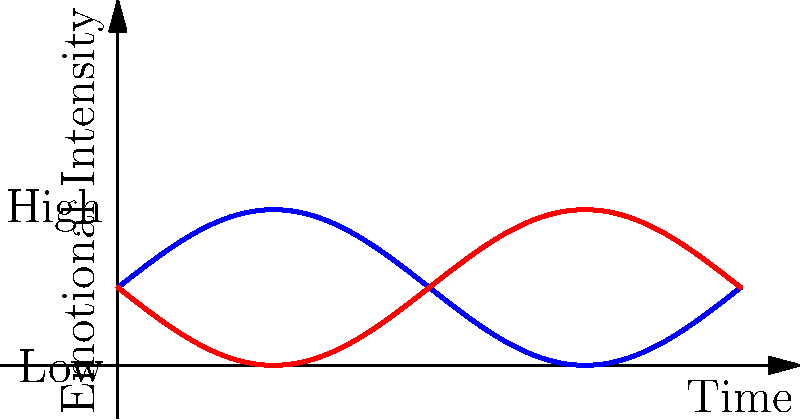As an expert in evaluating AI character realism, analyze the emotional trajectories of two characters over time as shown in the graph. What key observation can you make about the relationship between Character A's and Character B's emotional states, and how might this contribute to a more believable narrative arc? To analyze the emotional trajectories and their contribution to a believable narrative arc, let's break down the graph:

1. Character A (blue line):
   - Starts at a neutral emotional state
   - Rises to a peak of high emotional intensity around the midpoint
   - Returns to a neutral state by the end

2. Character B (red line):
   - Also starts at a neutral emotional state
   - Dips to a low point of emotional intensity around the midpoint
   - Returns to a neutral state by the end

3. Relationship between trajectories:
   - The curves are mirror images of each other
   - When Character A reaches peak intensity, Character B is at the lowest point
   - They intersect at the beginning, middle, and end, indicating moments of equal emotional states

4. Contribution to believable narrative arc:
   - The mirrored trajectories suggest a strong interconnection between the characters' emotional states
   - This pattern could represent a conflict or situation where one character's success corresponds with the other's failure
   - The return to a neutral state for both characters implies a resolution or equilibrium

5. Realism and believability:
   - The smooth transitions in emotional intensity feel natural and gradual
   - The symmetry provides a sense of balance to the overall narrative
   - The shared neutral points at beginning and end create a cohesive story structure

The key observation is that the characters' emotional states are inversely related, creating a dynamic interplay that can drive a compelling and believable narrative arc.
Answer: Inverse emotional relationship driving narrative tension and resolution 